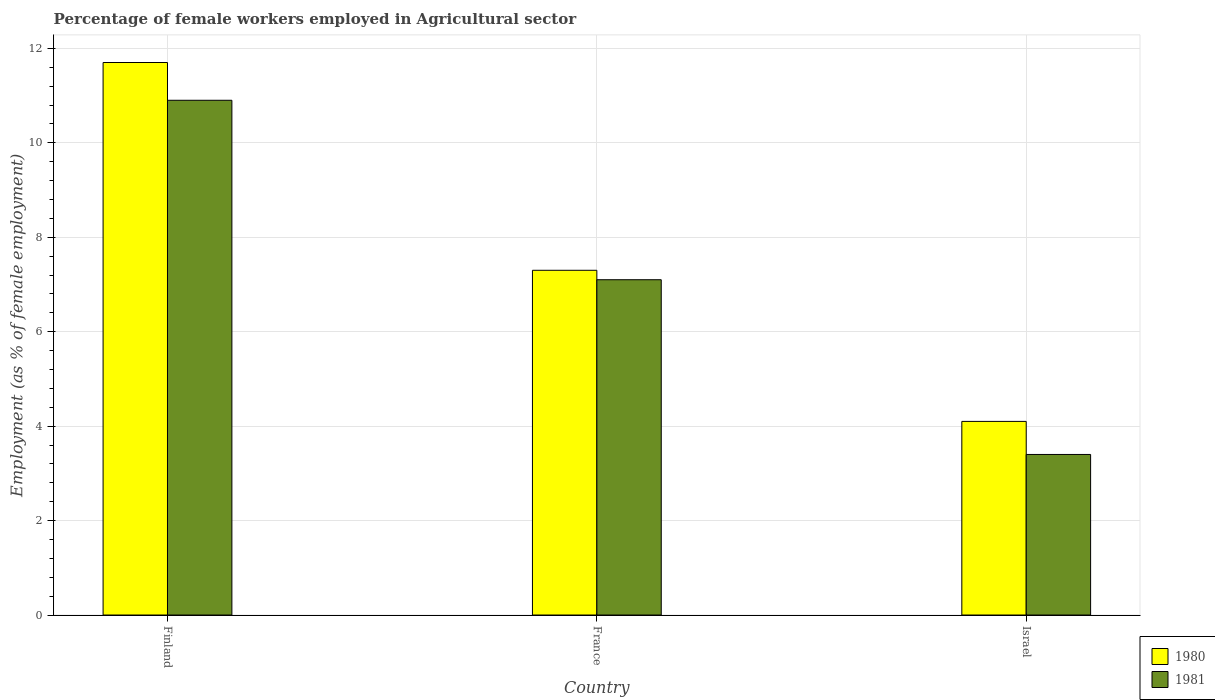How many different coloured bars are there?
Your response must be concise. 2. How many groups of bars are there?
Ensure brevity in your answer.  3. Are the number of bars per tick equal to the number of legend labels?
Your answer should be compact. Yes. Are the number of bars on each tick of the X-axis equal?
Give a very brief answer. Yes. In how many cases, is the number of bars for a given country not equal to the number of legend labels?
Keep it short and to the point. 0. What is the percentage of females employed in Agricultural sector in 1980 in Israel?
Make the answer very short. 4.1. Across all countries, what is the maximum percentage of females employed in Agricultural sector in 1980?
Your answer should be very brief. 11.7. Across all countries, what is the minimum percentage of females employed in Agricultural sector in 1980?
Your response must be concise. 4.1. What is the total percentage of females employed in Agricultural sector in 1980 in the graph?
Your response must be concise. 23.1. What is the difference between the percentage of females employed in Agricultural sector in 1980 in Finland and that in Israel?
Make the answer very short. 7.6. What is the difference between the percentage of females employed in Agricultural sector in 1980 in France and the percentage of females employed in Agricultural sector in 1981 in Israel?
Your answer should be very brief. 3.9. What is the average percentage of females employed in Agricultural sector in 1981 per country?
Provide a succinct answer. 7.13. What is the difference between the percentage of females employed in Agricultural sector of/in 1981 and percentage of females employed in Agricultural sector of/in 1980 in France?
Your answer should be compact. -0.2. What is the ratio of the percentage of females employed in Agricultural sector in 1980 in Finland to that in Israel?
Ensure brevity in your answer.  2.85. What is the difference between the highest and the second highest percentage of females employed in Agricultural sector in 1981?
Ensure brevity in your answer.  7.5. What is the difference between the highest and the lowest percentage of females employed in Agricultural sector in 1980?
Provide a short and direct response. 7.6. Is the sum of the percentage of females employed in Agricultural sector in 1980 in Finland and France greater than the maximum percentage of females employed in Agricultural sector in 1981 across all countries?
Your answer should be compact. Yes. What does the 1st bar from the right in Israel represents?
Give a very brief answer. 1981. Are all the bars in the graph horizontal?
Provide a short and direct response. No. What is the difference between two consecutive major ticks on the Y-axis?
Keep it short and to the point. 2. Does the graph contain grids?
Ensure brevity in your answer.  Yes. Where does the legend appear in the graph?
Give a very brief answer. Bottom right. How many legend labels are there?
Your answer should be very brief. 2. How are the legend labels stacked?
Provide a short and direct response. Vertical. What is the title of the graph?
Make the answer very short. Percentage of female workers employed in Agricultural sector. Does "2008" appear as one of the legend labels in the graph?
Offer a very short reply. No. What is the label or title of the Y-axis?
Offer a very short reply. Employment (as % of female employment). What is the Employment (as % of female employment) in 1980 in Finland?
Your response must be concise. 11.7. What is the Employment (as % of female employment) in 1981 in Finland?
Offer a terse response. 10.9. What is the Employment (as % of female employment) of 1980 in France?
Your response must be concise. 7.3. What is the Employment (as % of female employment) in 1981 in France?
Provide a short and direct response. 7.1. What is the Employment (as % of female employment) of 1980 in Israel?
Give a very brief answer. 4.1. What is the Employment (as % of female employment) in 1981 in Israel?
Make the answer very short. 3.4. Across all countries, what is the maximum Employment (as % of female employment) of 1980?
Offer a terse response. 11.7. Across all countries, what is the maximum Employment (as % of female employment) in 1981?
Make the answer very short. 10.9. Across all countries, what is the minimum Employment (as % of female employment) in 1980?
Provide a short and direct response. 4.1. Across all countries, what is the minimum Employment (as % of female employment) of 1981?
Offer a terse response. 3.4. What is the total Employment (as % of female employment) in 1980 in the graph?
Your answer should be very brief. 23.1. What is the total Employment (as % of female employment) of 1981 in the graph?
Give a very brief answer. 21.4. What is the difference between the Employment (as % of female employment) in 1981 in Finland and that in Israel?
Your response must be concise. 7.5. What is the difference between the Employment (as % of female employment) of 1981 in France and that in Israel?
Your response must be concise. 3.7. What is the difference between the Employment (as % of female employment) in 1980 in Finland and the Employment (as % of female employment) in 1981 in France?
Provide a succinct answer. 4.6. What is the difference between the Employment (as % of female employment) of 1980 in Finland and the Employment (as % of female employment) of 1981 in Israel?
Keep it short and to the point. 8.3. What is the difference between the Employment (as % of female employment) in 1980 in France and the Employment (as % of female employment) in 1981 in Israel?
Offer a terse response. 3.9. What is the average Employment (as % of female employment) in 1980 per country?
Give a very brief answer. 7.7. What is the average Employment (as % of female employment) in 1981 per country?
Give a very brief answer. 7.13. What is the ratio of the Employment (as % of female employment) in 1980 in Finland to that in France?
Keep it short and to the point. 1.6. What is the ratio of the Employment (as % of female employment) of 1981 in Finland to that in France?
Provide a succinct answer. 1.54. What is the ratio of the Employment (as % of female employment) in 1980 in Finland to that in Israel?
Your answer should be very brief. 2.85. What is the ratio of the Employment (as % of female employment) of 1981 in Finland to that in Israel?
Your answer should be very brief. 3.21. What is the ratio of the Employment (as % of female employment) in 1980 in France to that in Israel?
Offer a very short reply. 1.78. What is the ratio of the Employment (as % of female employment) of 1981 in France to that in Israel?
Your response must be concise. 2.09. What is the difference between the highest and the second highest Employment (as % of female employment) of 1980?
Your answer should be very brief. 4.4. 